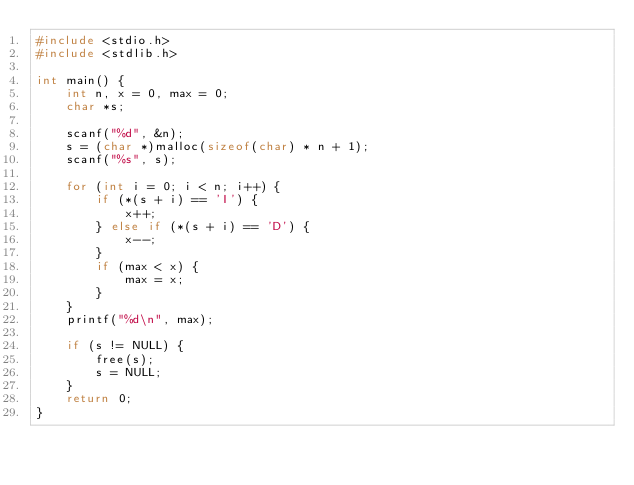<code> <loc_0><loc_0><loc_500><loc_500><_C_>#include <stdio.h>
#include <stdlib.h>

int main() {
    int n, x = 0, max = 0;
    char *s;

    scanf("%d", &n);
    s = (char *)malloc(sizeof(char) * n + 1);
    scanf("%s", s);

    for (int i = 0; i < n; i++) {
        if (*(s + i) == 'I') {
            x++;
        } else if (*(s + i) == 'D') {
            x--;
        }
        if (max < x) {
            max = x;
        }
    }
    printf("%d\n", max);

    if (s != NULL) {
        free(s);
        s = NULL;
    }
    return 0;
}
</code> 